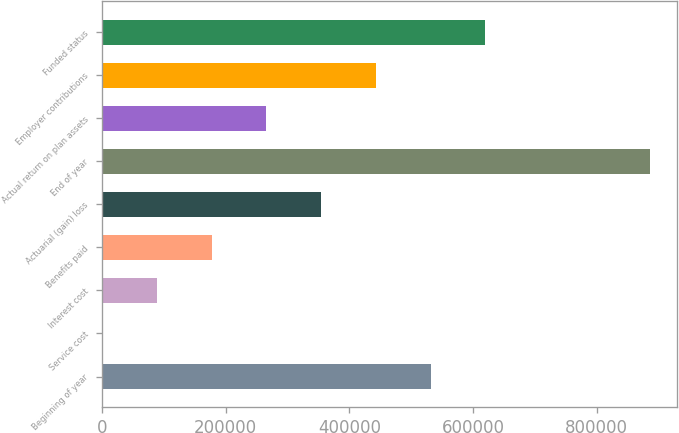Convert chart to OTSL. <chart><loc_0><loc_0><loc_500><loc_500><bar_chart><fcel>Beginning of year<fcel>Service cost<fcel>Interest cost<fcel>Benefits paid<fcel>Actuarial (gain) loss<fcel>End of year<fcel>Actual return on plan assets<fcel>Employer contributions<fcel>Funded status<nl><fcel>531470<fcel>378<fcel>88893.3<fcel>177409<fcel>354439<fcel>885531<fcel>265924<fcel>442954<fcel>619985<nl></chart> 